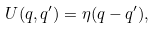<formula> <loc_0><loc_0><loc_500><loc_500>U ( q , q ^ { \prime } ) = \eta ( q - q ^ { \prime } ) ,</formula> 